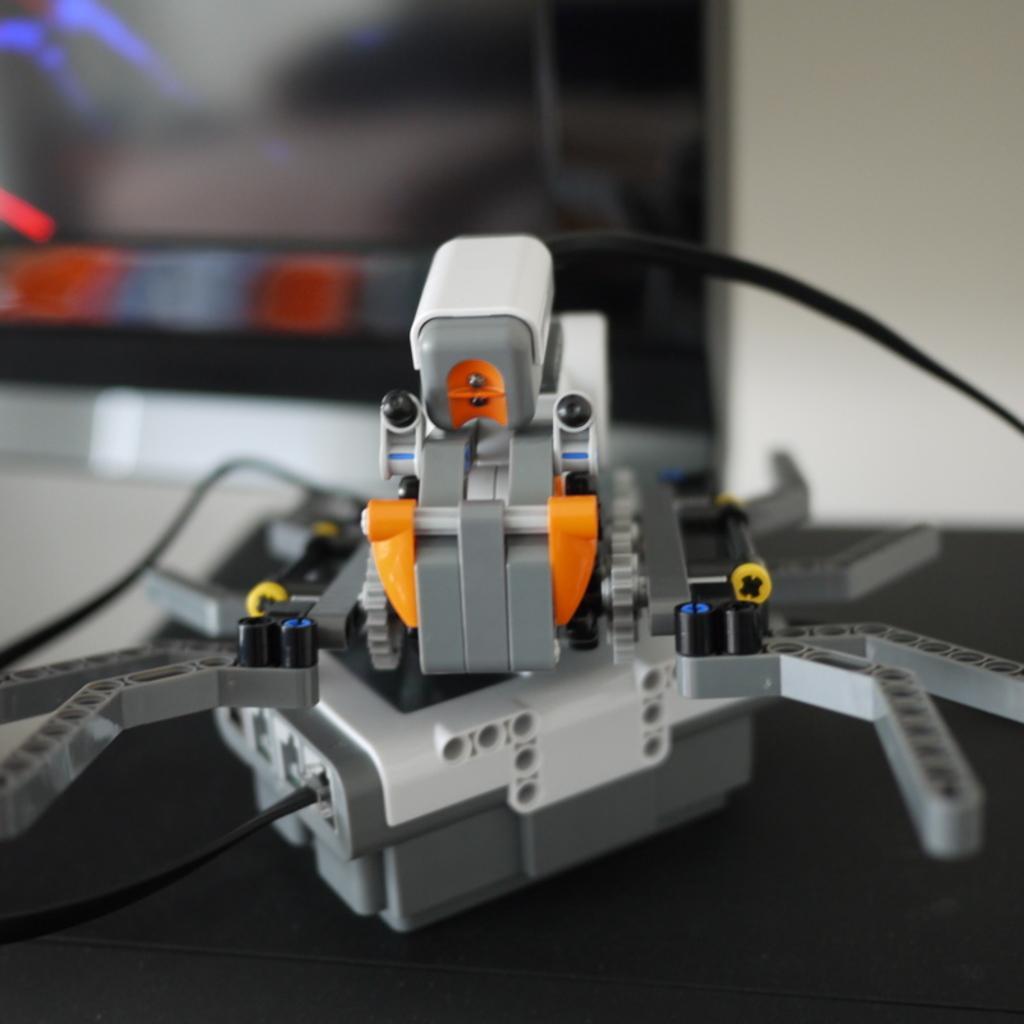In one or two sentences, can you explain what this image depicts? In this image there is an object on the table. Background is blurry. 